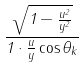<formula> <loc_0><loc_0><loc_500><loc_500>\frac { \sqrt { 1 - \frac { u ^ { 2 } } { y ^ { 2 } } } } { 1 \cdot \frac { u } { y } \cos \theta _ { k } }</formula> 